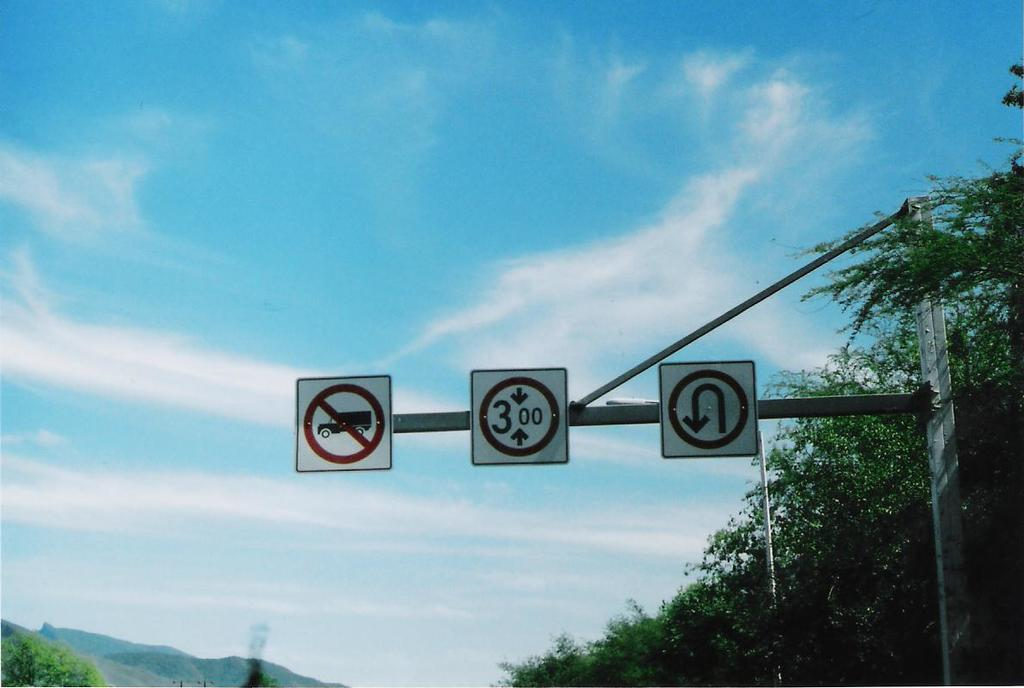Provide a one-sentence caption for the provided image. three road signs on a pole, instructing that no trucks are allowed, vehicle can not be more than 3.00 and lastly no u turns are allowed. 